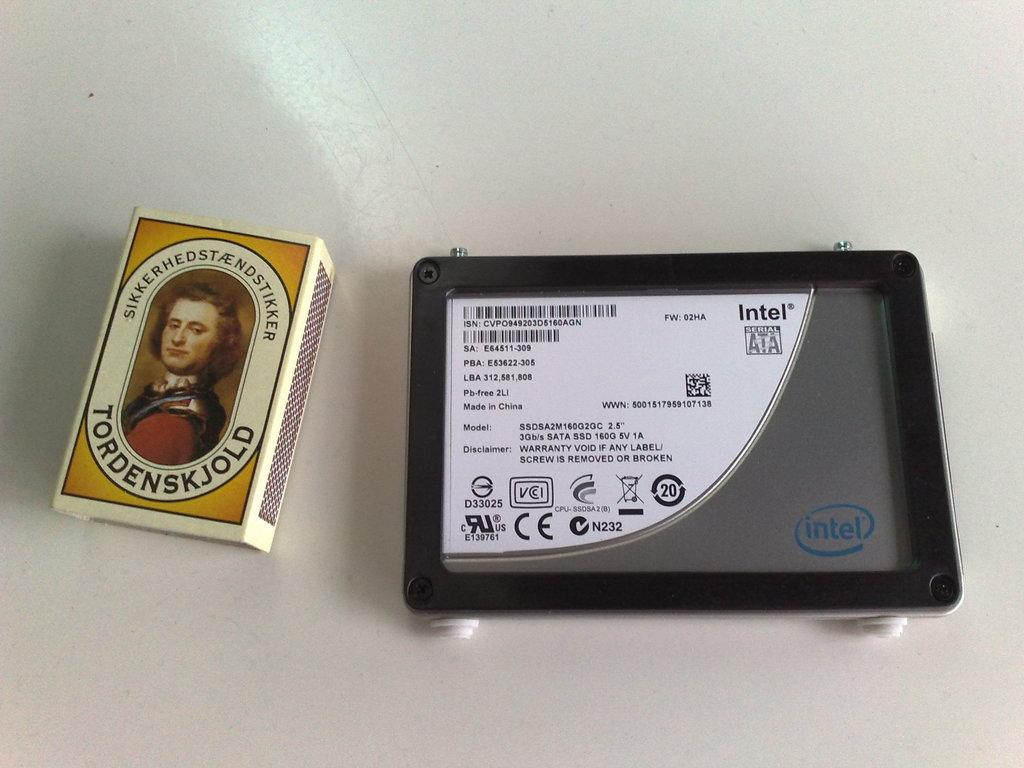What objects can be seen in the image? There is a matchbox and an iPad in the image. What is the color of the background in the image? The background of the image is white. How many doors are visible in the image? There are no doors present in the image. What type of pen is being used to write on the iPad in the image? There is no pen visible in the image, and the iPad is not being used for writing. 